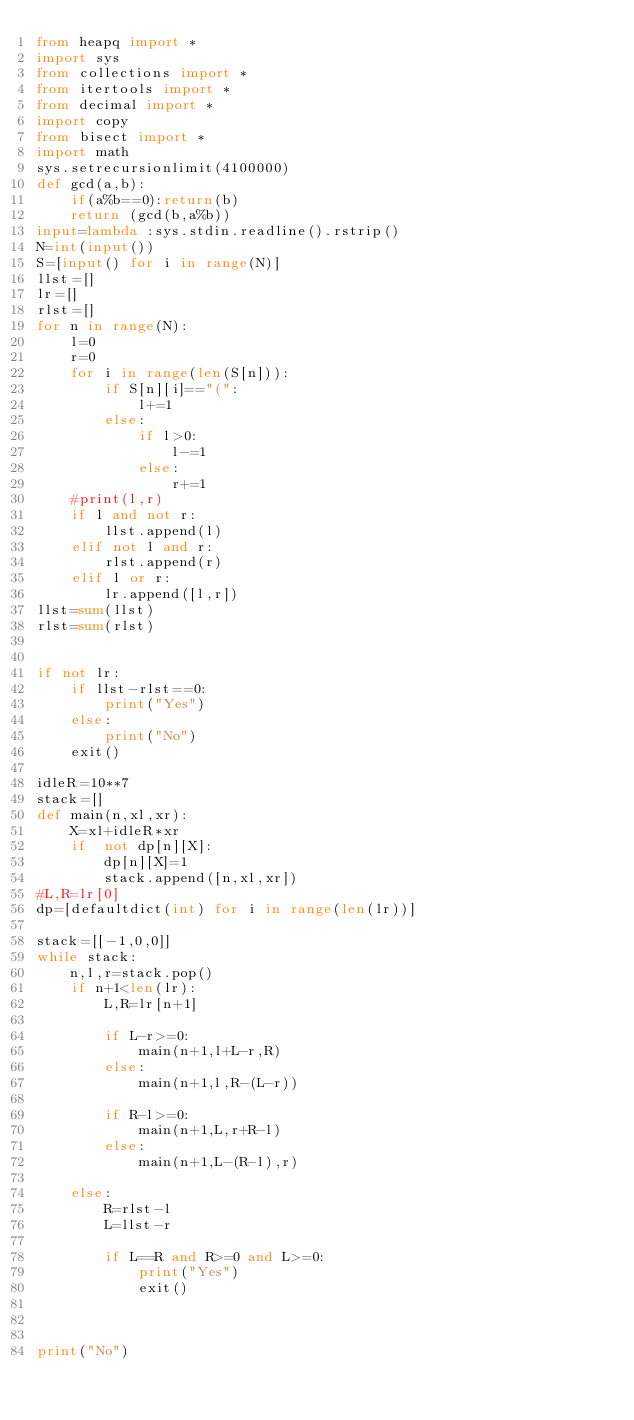Convert code to text. <code><loc_0><loc_0><loc_500><loc_500><_Python_>from heapq import *
import sys
from collections import *
from itertools import *
from decimal import *
import copy
from bisect import *
import math
sys.setrecursionlimit(4100000)
def gcd(a,b):
    if(a%b==0):return(b)
    return (gcd(b,a%b))
input=lambda :sys.stdin.readline().rstrip()
N=int(input())
S=[input() for i in range(N)]
llst=[]
lr=[]
rlst=[]
for n in range(N):
    l=0
    r=0
    for i in range(len(S[n])):
        if S[n][i]=="(":
            l+=1
        else:
            if l>0:
                l-=1
            else:
                r+=1
    #print(l,r)
    if l and not r:
        llst.append(l)
    elif not l and r:
        rlst.append(r)
    elif l or r:
        lr.append([l,r])
llst=sum(llst)
rlst=sum(rlst)


if not lr:
    if llst-rlst==0:
        print("Yes")
    else:
        print("No")
    exit()

idleR=10**7
stack=[]
def main(n,xl,xr):
    X=xl+idleR*xr
    if  not dp[n][X]:
        dp[n][X]=1
        stack.append([n,xl,xr])
#L,R=lr[0]
dp=[defaultdict(int) for i in range(len(lr))]

stack=[[-1,0,0]]
while stack:
    n,l,r=stack.pop()
    if n+1<len(lr):
        L,R=lr[n+1]

        if L-r>=0:
            main(n+1,l+L-r,R)
        else:
            main(n+1,l,R-(L-r))

        if R-l>=0:
            main(n+1,L,r+R-l)
        else:
            main(n+1,L-(R-l),r)

    else:
        R=rlst-l
        L=llst-r

        if L==R and R>=0 and L>=0:
            print("Yes")
            exit()



print("No")
</code> 